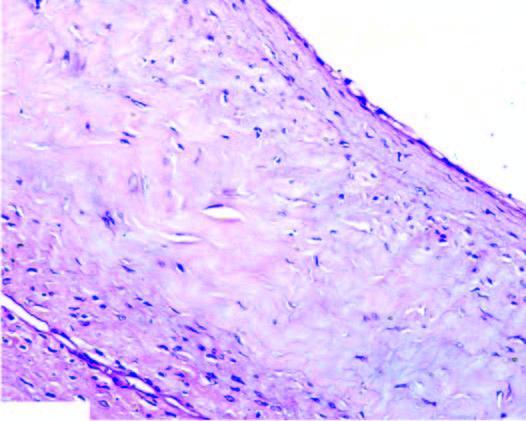what is composed of dense connective tissue lined internally by flattened lining?
Answer the question using a single word or phrase. Cyst wall 